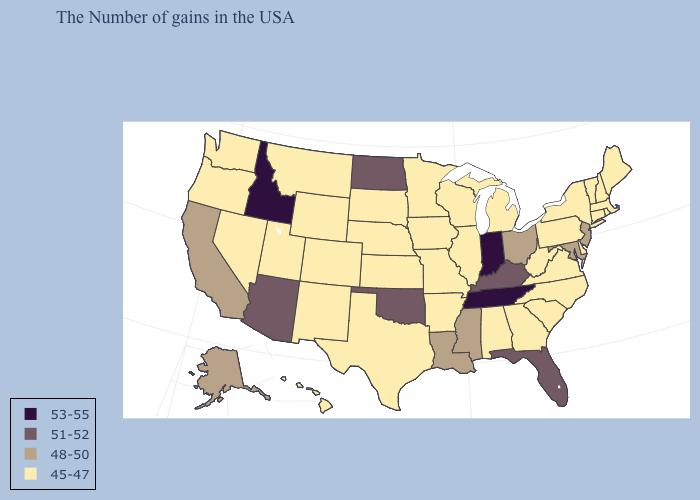What is the highest value in states that border New York?
Quick response, please. 48-50. Name the states that have a value in the range 48-50?
Quick response, please. New Jersey, Maryland, Ohio, Mississippi, Louisiana, California, Alaska. Among the states that border Virginia , does Tennessee have the lowest value?
Be succinct. No. Does Indiana have the highest value in the MidWest?
Short answer required. Yes. Among the states that border Iowa , which have the highest value?
Be succinct. Wisconsin, Illinois, Missouri, Minnesota, Nebraska, South Dakota. Does Massachusetts have a lower value than Delaware?
Short answer required. No. Does the first symbol in the legend represent the smallest category?
Keep it brief. No. What is the value of Kentucky?
Be succinct. 51-52. What is the value of Oklahoma?
Be succinct. 51-52. Does Michigan have the same value as Iowa?
Give a very brief answer. Yes. What is the value of Maryland?
Give a very brief answer. 48-50. Which states have the lowest value in the USA?
Write a very short answer. Maine, Massachusetts, Rhode Island, New Hampshire, Vermont, Connecticut, New York, Delaware, Pennsylvania, Virginia, North Carolina, South Carolina, West Virginia, Georgia, Michigan, Alabama, Wisconsin, Illinois, Missouri, Arkansas, Minnesota, Iowa, Kansas, Nebraska, Texas, South Dakota, Wyoming, Colorado, New Mexico, Utah, Montana, Nevada, Washington, Oregon, Hawaii. What is the value of Arkansas?
Give a very brief answer. 45-47. Name the states that have a value in the range 51-52?
Be succinct. Florida, Kentucky, Oklahoma, North Dakota, Arizona. What is the highest value in the USA?
Answer briefly. 53-55. 